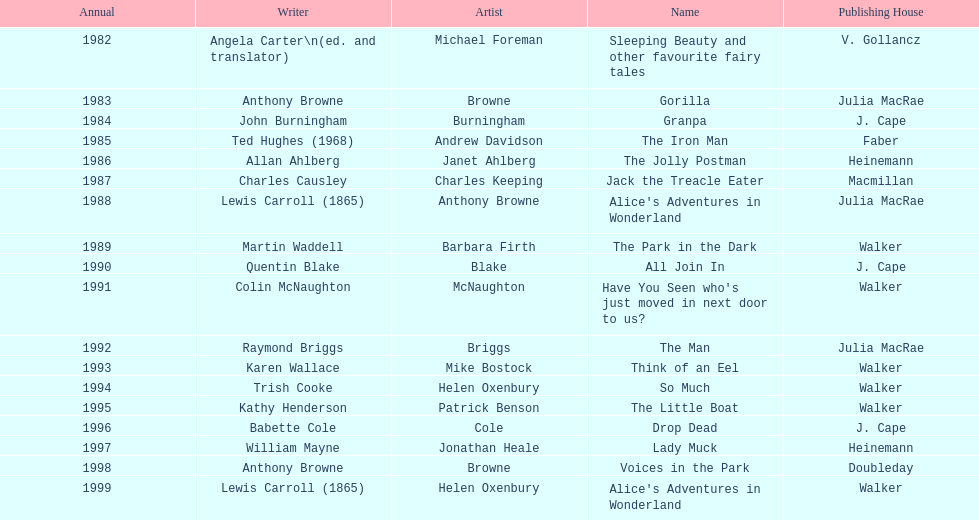What's the difference in years between angela carter's title and anthony browne's? 1. 